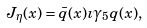Convert formula to latex. <formula><loc_0><loc_0><loc_500><loc_500>J _ { \eta } ( x ) = \bar { q } ( x ) \imath \gamma _ { 5 } q ( x ) ,</formula> 